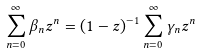Convert formula to latex. <formula><loc_0><loc_0><loc_500><loc_500>\sum _ { n = 0 } ^ { \infty } \beta _ { n } z ^ { n } = ( 1 - z ) ^ { - 1 } \sum _ { n = 0 } ^ { \infty } \gamma _ { n } z ^ { n }</formula> 